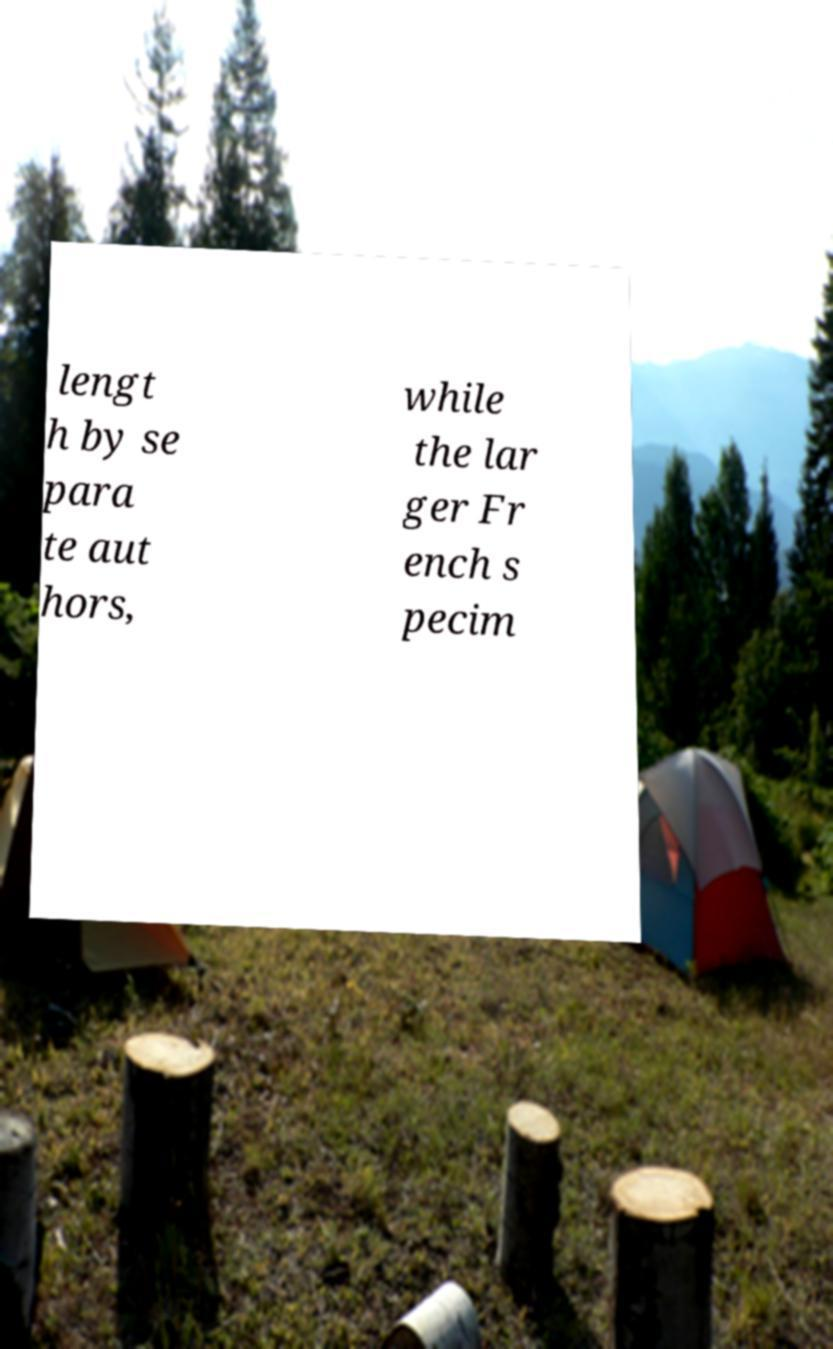Could you extract and type out the text from this image? lengt h by se para te aut hors, while the lar ger Fr ench s pecim 